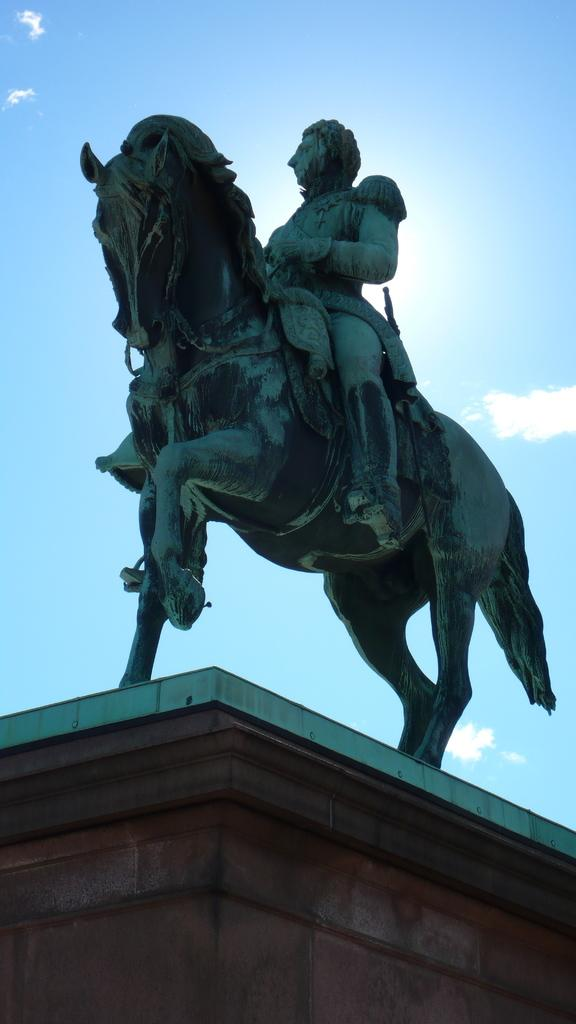What is the main subject of the statue in the image? The statue is of a man sitting on a horse. What part of a building can be seen in the image? There is a basement visible in the image. What is visible in the background of the image? The sky is visible in the image. What type of weather can be inferred from the sky in the image? Clouds are present in the sky, which suggests that it might be a partly cloudy day. What type of railway is visible in the image? There is no railway present in the image. How many men are visible in the image? There is only one man visible in the image, and that is the man depicted in the statue. 